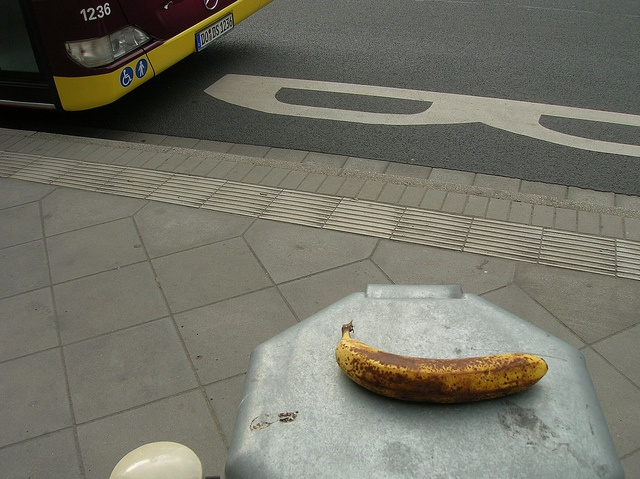Describe the objects in this image and their specific colors. I can see bus in black, olive, and gray tones and banana in black, olive, and maroon tones in this image. 